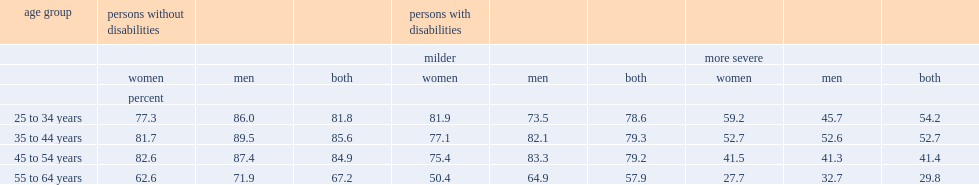Which group of people with either milder disabilities or no disabilities had a higher employment rate? women among aged 55 to 65 years or men? Men men. Which group of people with more severe disabilities had a higher employment rate? women among aged 25 to 34 years or men? Women. 